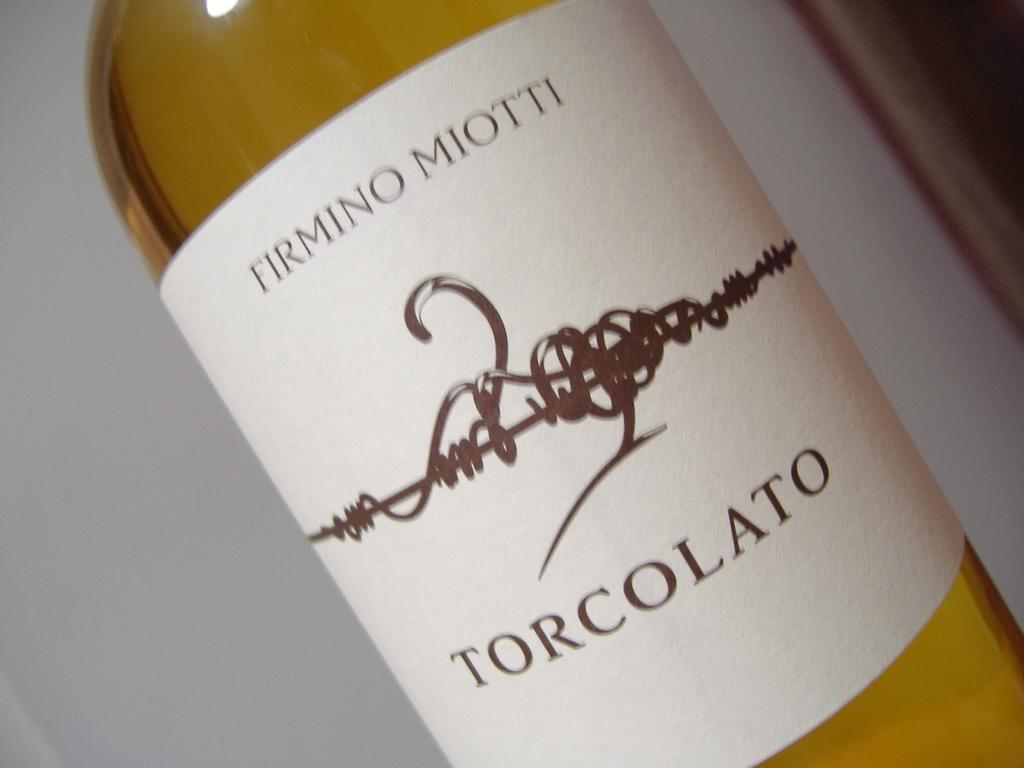<image>
Create a compact narrative representing the image presented. A bottle of wine that says Torcolato on it in brown letters. 